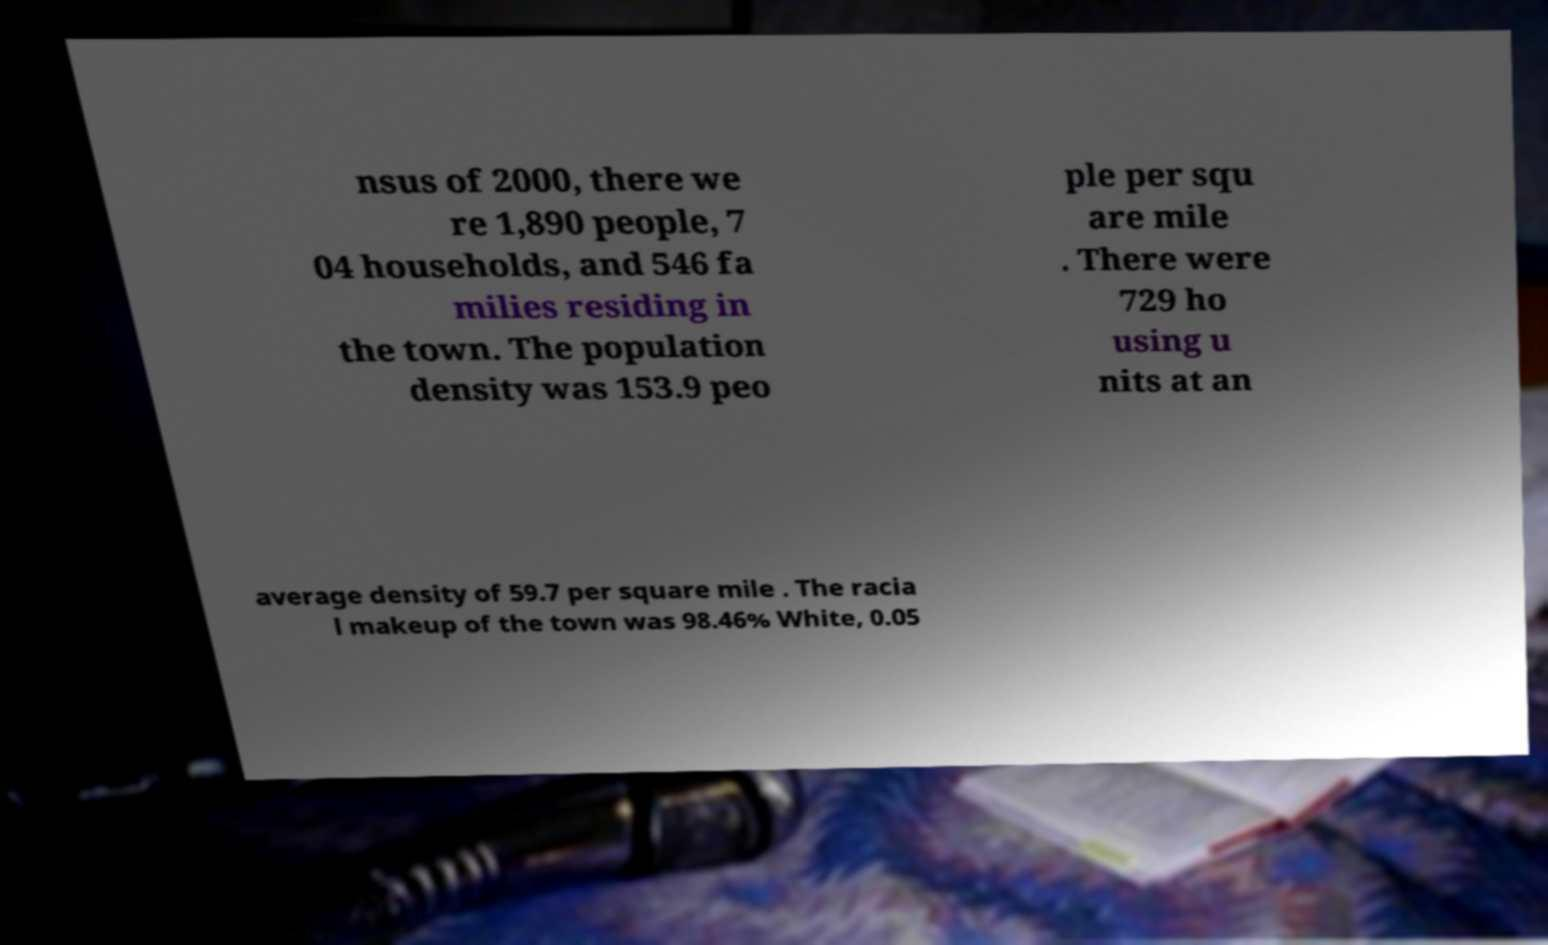Can you read and provide the text displayed in the image?This photo seems to have some interesting text. Can you extract and type it out for me? nsus of 2000, there we re 1,890 people, 7 04 households, and 546 fa milies residing in the town. The population density was 153.9 peo ple per squ are mile . There were 729 ho using u nits at an average density of 59.7 per square mile . The racia l makeup of the town was 98.46% White, 0.05 